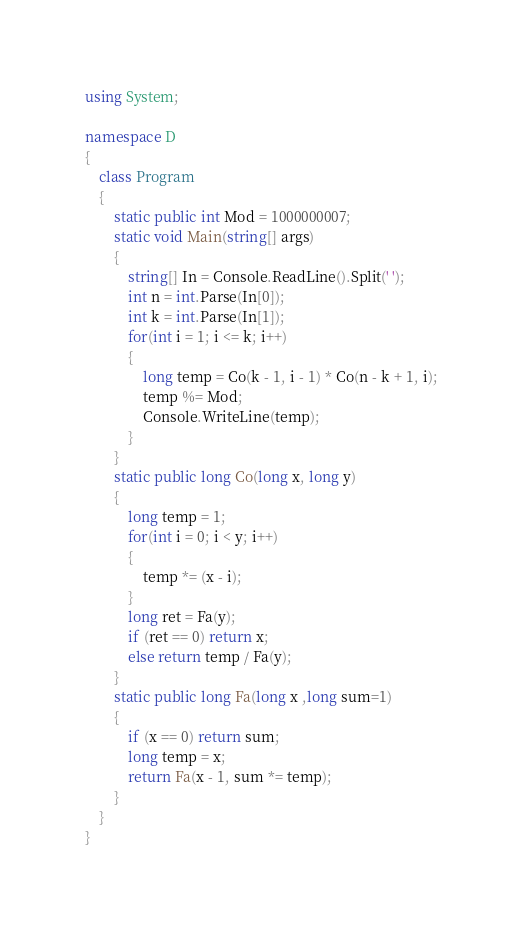Convert code to text. <code><loc_0><loc_0><loc_500><loc_500><_C#_>using System;

namespace D
{
    class Program
    {
        static public int Mod = 1000000007;
        static void Main(string[] args)
        {
            string[] In = Console.ReadLine().Split(' ');
            int n = int.Parse(In[0]);
            int k = int.Parse(In[1]);
            for(int i = 1; i <= k; i++)
            {
                long temp = Co(k - 1, i - 1) * Co(n - k + 1, i);
                temp %= Mod;
                Console.WriteLine(temp);
            }
        }
        static public long Co(long x, long y)
        {
            long temp = 1;
            for(int i = 0; i < y; i++)
            {
                temp *= (x - i);
            }
            long ret = Fa(y);
            if (ret == 0) return x;
            else return temp / Fa(y);
        }
        static public long Fa(long x ,long sum=1)
        {
            if (x == 0) return sum;
            long temp = x;
            return Fa(x - 1, sum *= temp);
        }
    }
}
</code> 